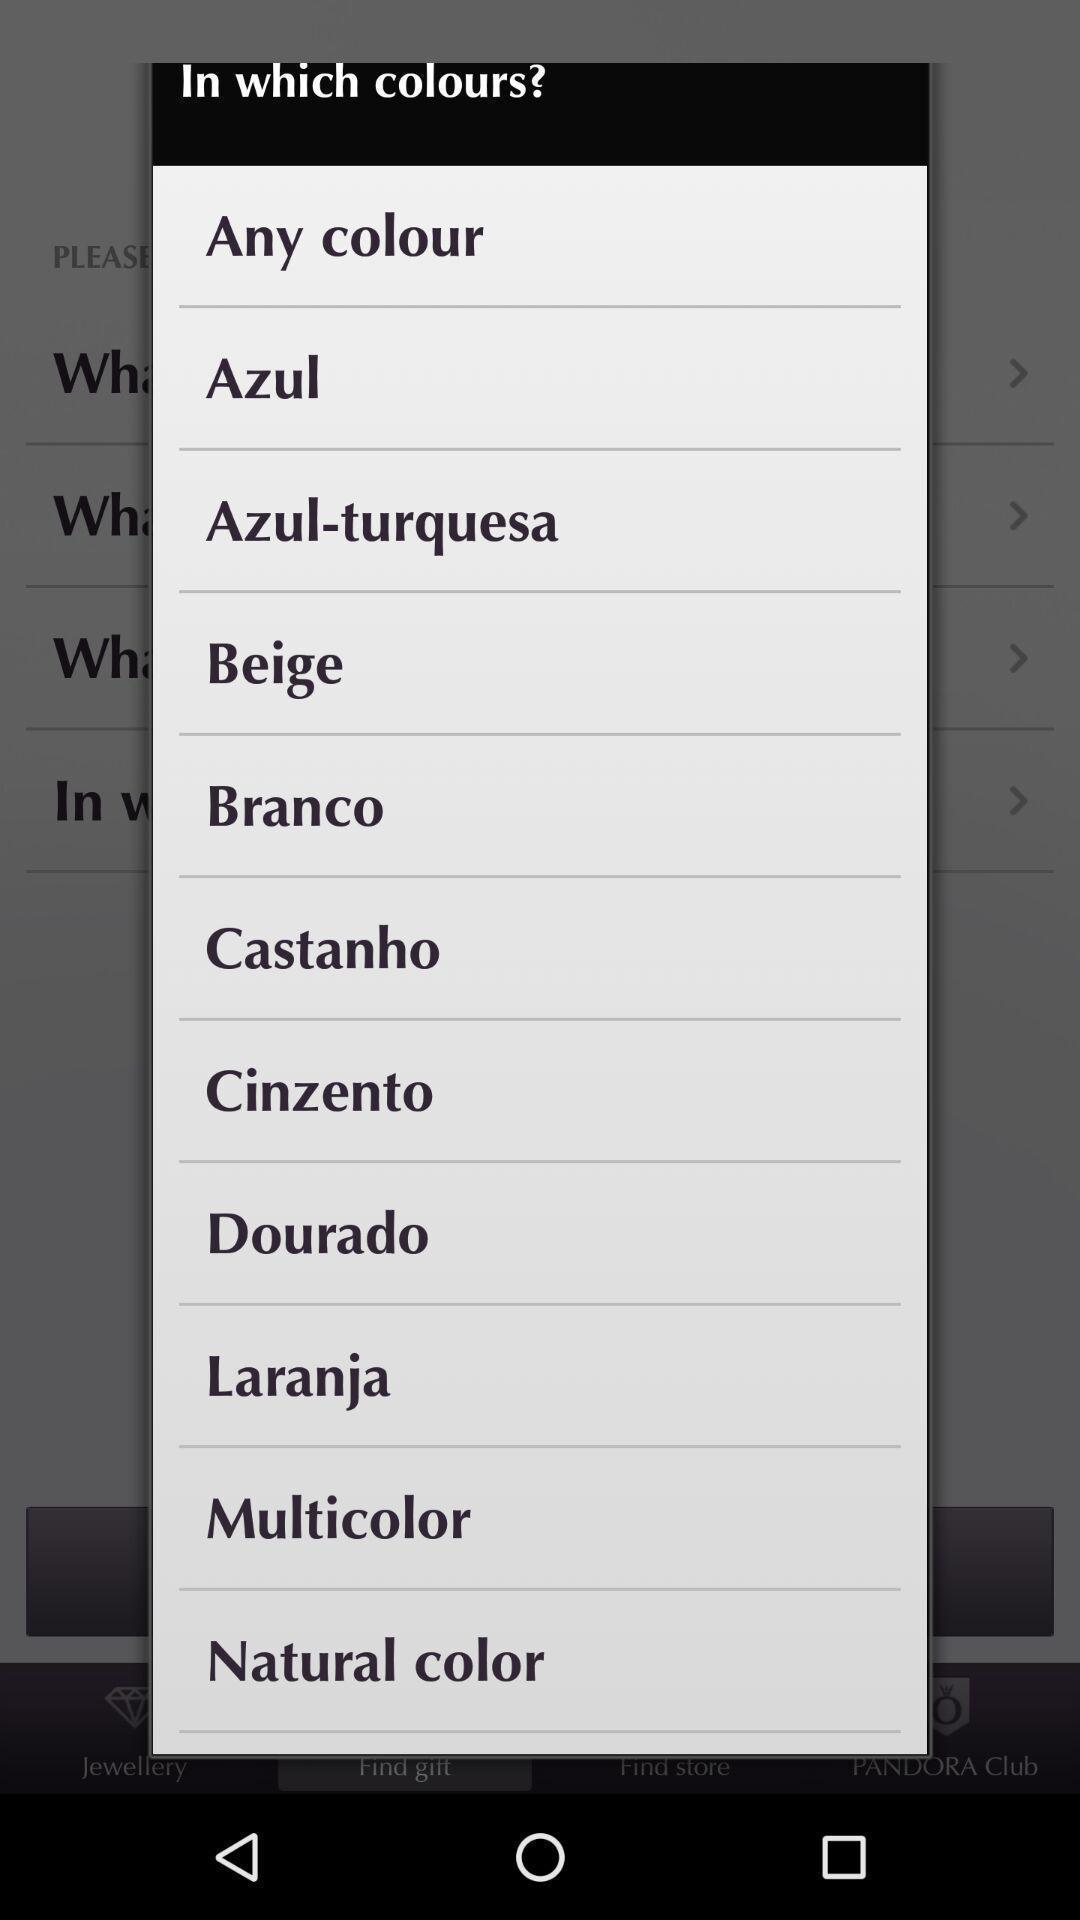Give me a narrative description of this picture. Popup displaying options in the app. 